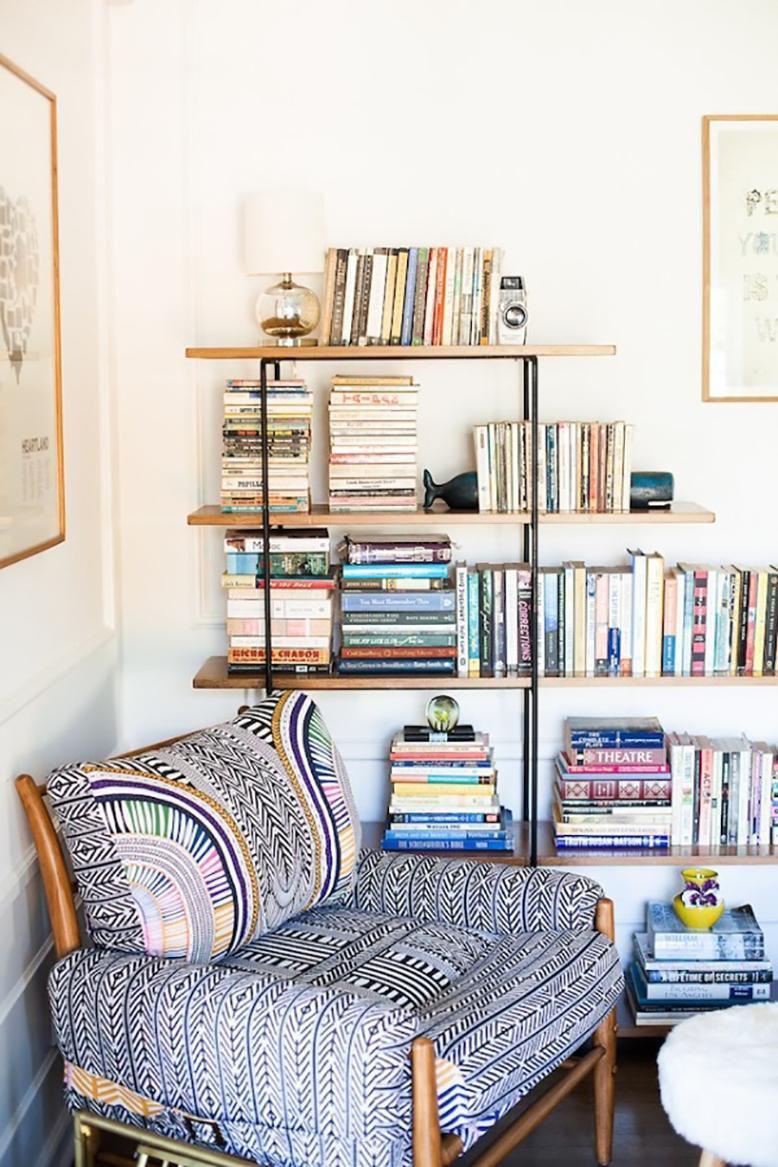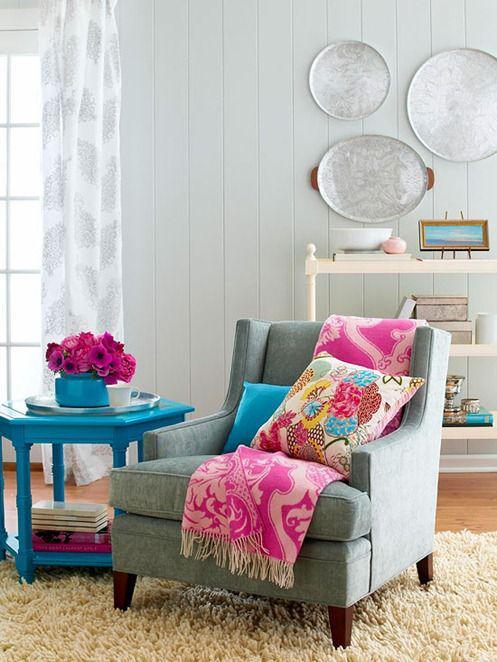The first image is the image on the left, the second image is the image on the right. Examine the images to the left and right. Is the description "A white window is visible in the right image." accurate? Answer yes or no. Yes. The first image is the image on the left, the second image is the image on the right. Evaluate the accuracy of this statement regarding the images: "At least one colorful pillow is displayed in front of a wall featuring round decorative items.". Is it true? Answer yes or no. Yes. 